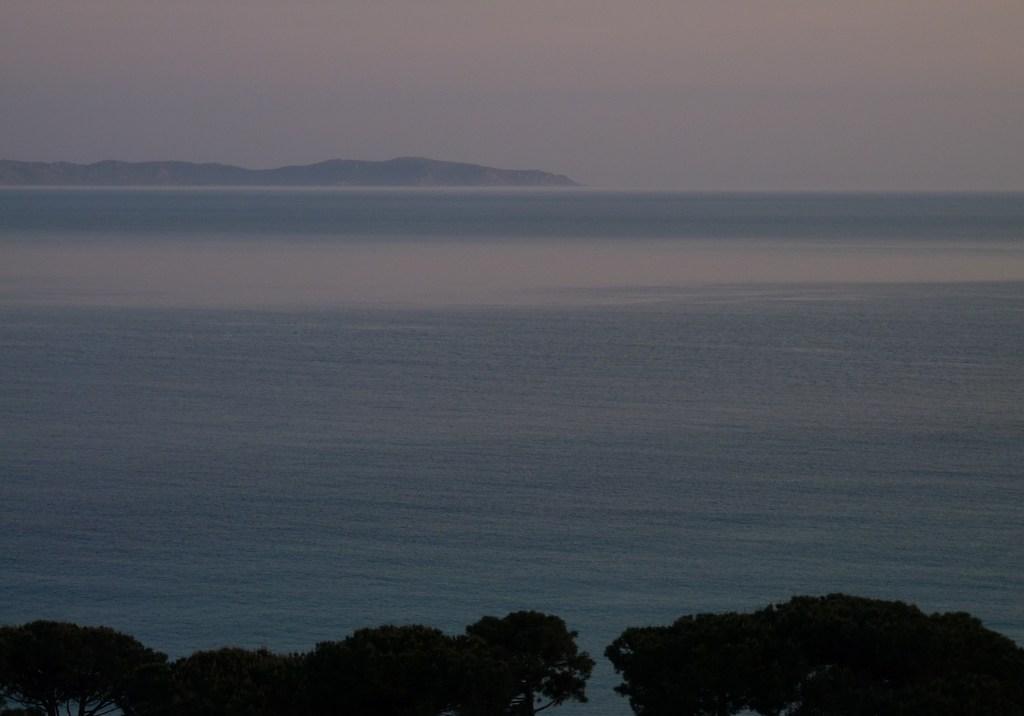In one or two sentences, can you explain what this image depicts? In this picture we can see the beautiful view of the sea water. In the front bottom side there are some trees. In the background there are some mountains. 